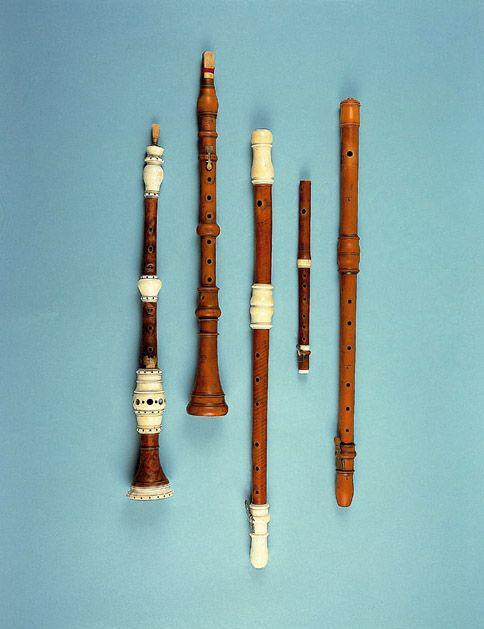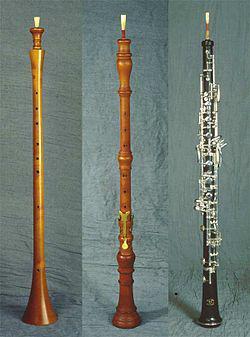The first image is the image on the left, the second image is the image on the right. For the images shown, is this caption "There are three clarinets in the right image." true? Answer yes or no. Yes. The first image is the image on the left, the second image is the image on the right. Examine the images to the left and right. Is the description "One image contains exactly three wind instruments and the other contains exactly five." accurate? Answer yes or no. Yes. 